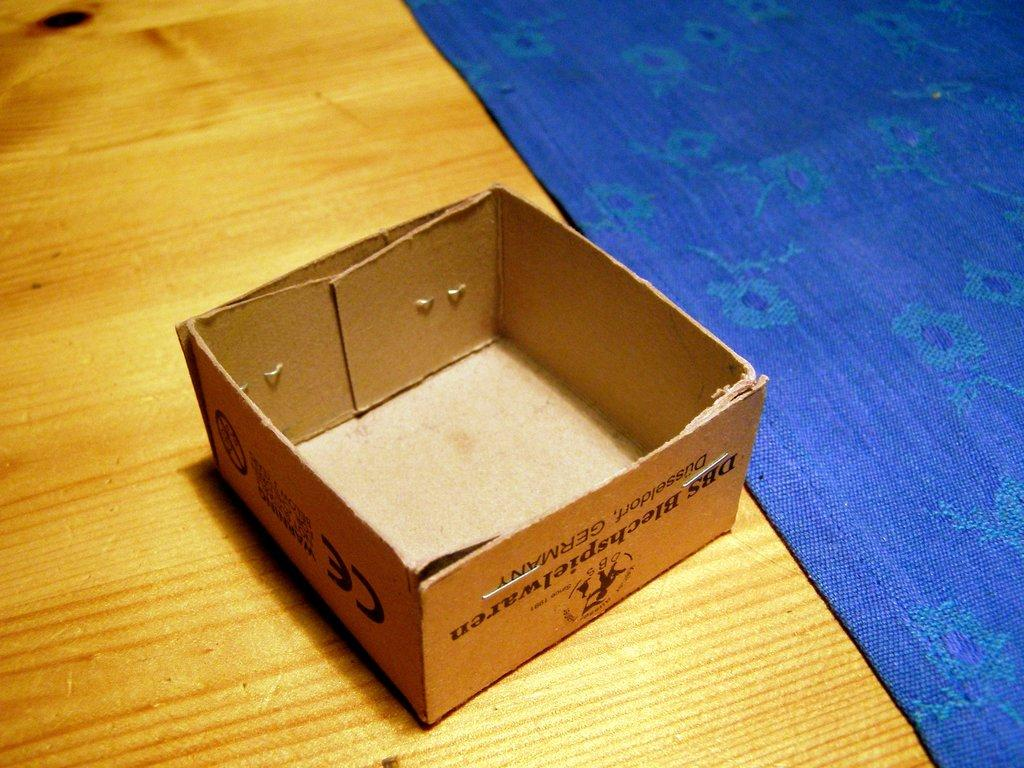<image>
Create a compact narrative representing the image presented. A small stapled box from Germany sits next to a placemat. 